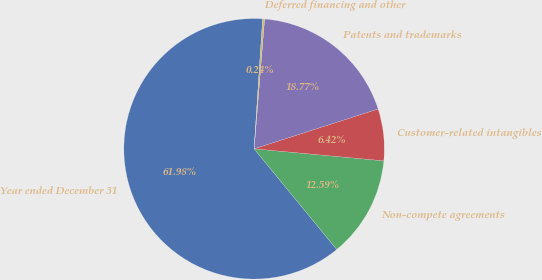<chart> <loc_0><loc_0><loc_500><loc_500><pie_chart><fcel>Year ended December 31<fcel>Non-compete agreements<fcel>Customer-related intangibles<fcel>Patents and trademarks<fcel>Deferred financing and other<nl><fcel>61.98%<fcel>12.59%<fcel>6.42%<fcel>18.77%<fcel>0.24%<nl></chart> 